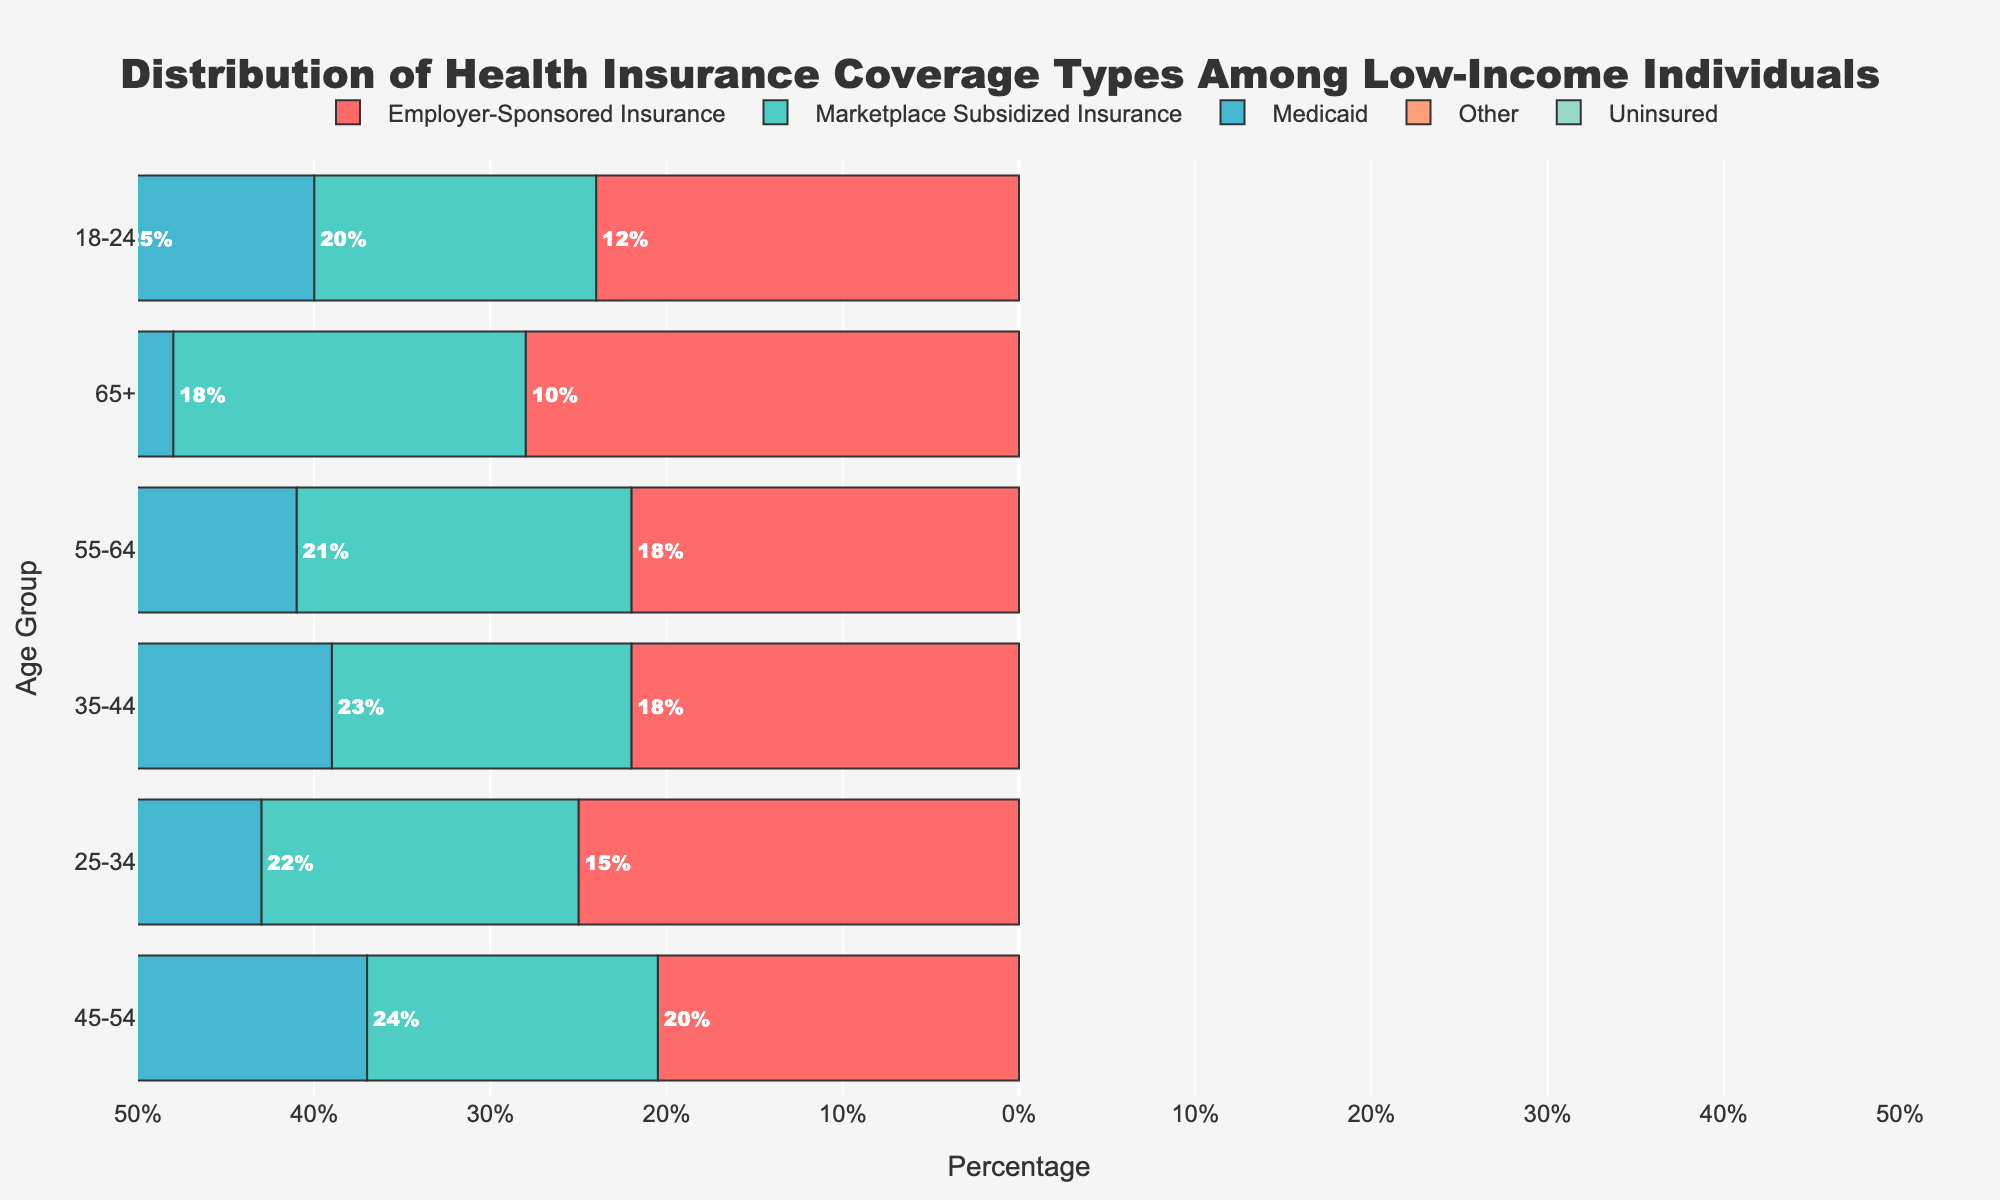What age group has the highest percentage of people with Medicaid coverage? Check the length of the bars for Medicaid coverage. The 25-34 age group has the longest bar in this category.
Answer: 25-34 Which age group has the lowest percentage of people with Employer-Sponsored Insurance? Compare the lengths of the Employer-Sponsored Insurance bars for all age groups. The 65+ age group's bar is the shortest.
Answer: 65+ What is the total percentage of uninsured individuals across all age groups? Sum the percentages of uninsured individuals from all age groups (10 + 9 + 8 + 7 + 10 + 14).
Answer: 58% Which age group has the highest percentage of uninsured individuals? Look for the longest bar in the uninsured category. The 65+ age group has the longest bar.
Answer: 65+ Between the 18-24 and 25-34 age groups, which has a higher percentage of individuals with Marketplace Subsidized Insurance? Compare the lengths of the bars for Marketplace Subsidized Insurance. The 25-34 age group has a longer bar than the 18-24 age group.
Answer: 25-34 How does the percentage of individuals with Medicaid coverage change from the 35-44 age group to the 55-64 age group? Subtract the Medicaid percentage of the 55-64 age group (22) from that of the 35-44 age group (26). The change is 26 - 22.
Answer: Decrease by 4 Which age group has the highest total percentage of people with either Medicaid or Employer-Sponsored Insurance? Sum the percentages for Medicaid and Employer-Sponsored Insurance in each age group and find the highest. For the 25-34 age group: Medicaid (28) + Employer-Sponsored (15) = 43%. Compare all sums.
Answer: 25-34 What is the average percentage of people with Marketplace Subsidized Insurance across all age groups? Sum the Marketplace Subsidized Insurance percentages (20 + 22 + 23 + 24 + 21 + 18) then divide by the number of age groups (6). Average = (128) / 6 = 21.33
Answer: 21.33% 